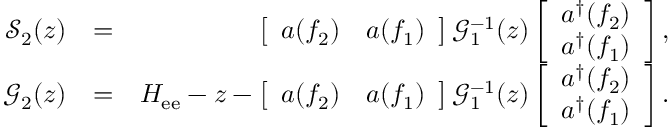Convert formula to latex. <formula><loc_0><loc_0><loc_500><loc_500>\begin{array} { r l r } { \mathcal { S } _ { 2 } ( z ) } & { = } & { \left [ \begin{array} { c c } { a \, \left ( f _ { 2 } \right ) } & { a \, \left ( f _ { 1 } \right ) } \end{array} \right ] \mathcal { G } _ { 1 } ^ { - 1 } ( z ) \left [ \begin{array} { c } { a ^ { \dag } \, \left ( f _ { 2 } \right ) } \\ { a ^ { \dag } \, \left ( f _ { 1 } \right ) } \end{array} \right ] , } \\ { \mathcal { G } _ { 2 } ( z ) } & { = } & { H _ { e e } - z - \left [ \begin{array} { c c } { a \, \left ( f _ { 2 } \right ) } & { a \, \left ( f _ { 1 } \right ) } \end{array} \right ] \mathcal { G } _ { 1 } ^ { - 1 } ( z ) \left [ \begin{array} { c } { a ^ { \dag } \, \left ( f _ { 2 } \right ) } \\ { a ^ { \dag } \, \left ( f _ { 1 } \right ) } \end{array} \right ] . } \end{array}</formula> 